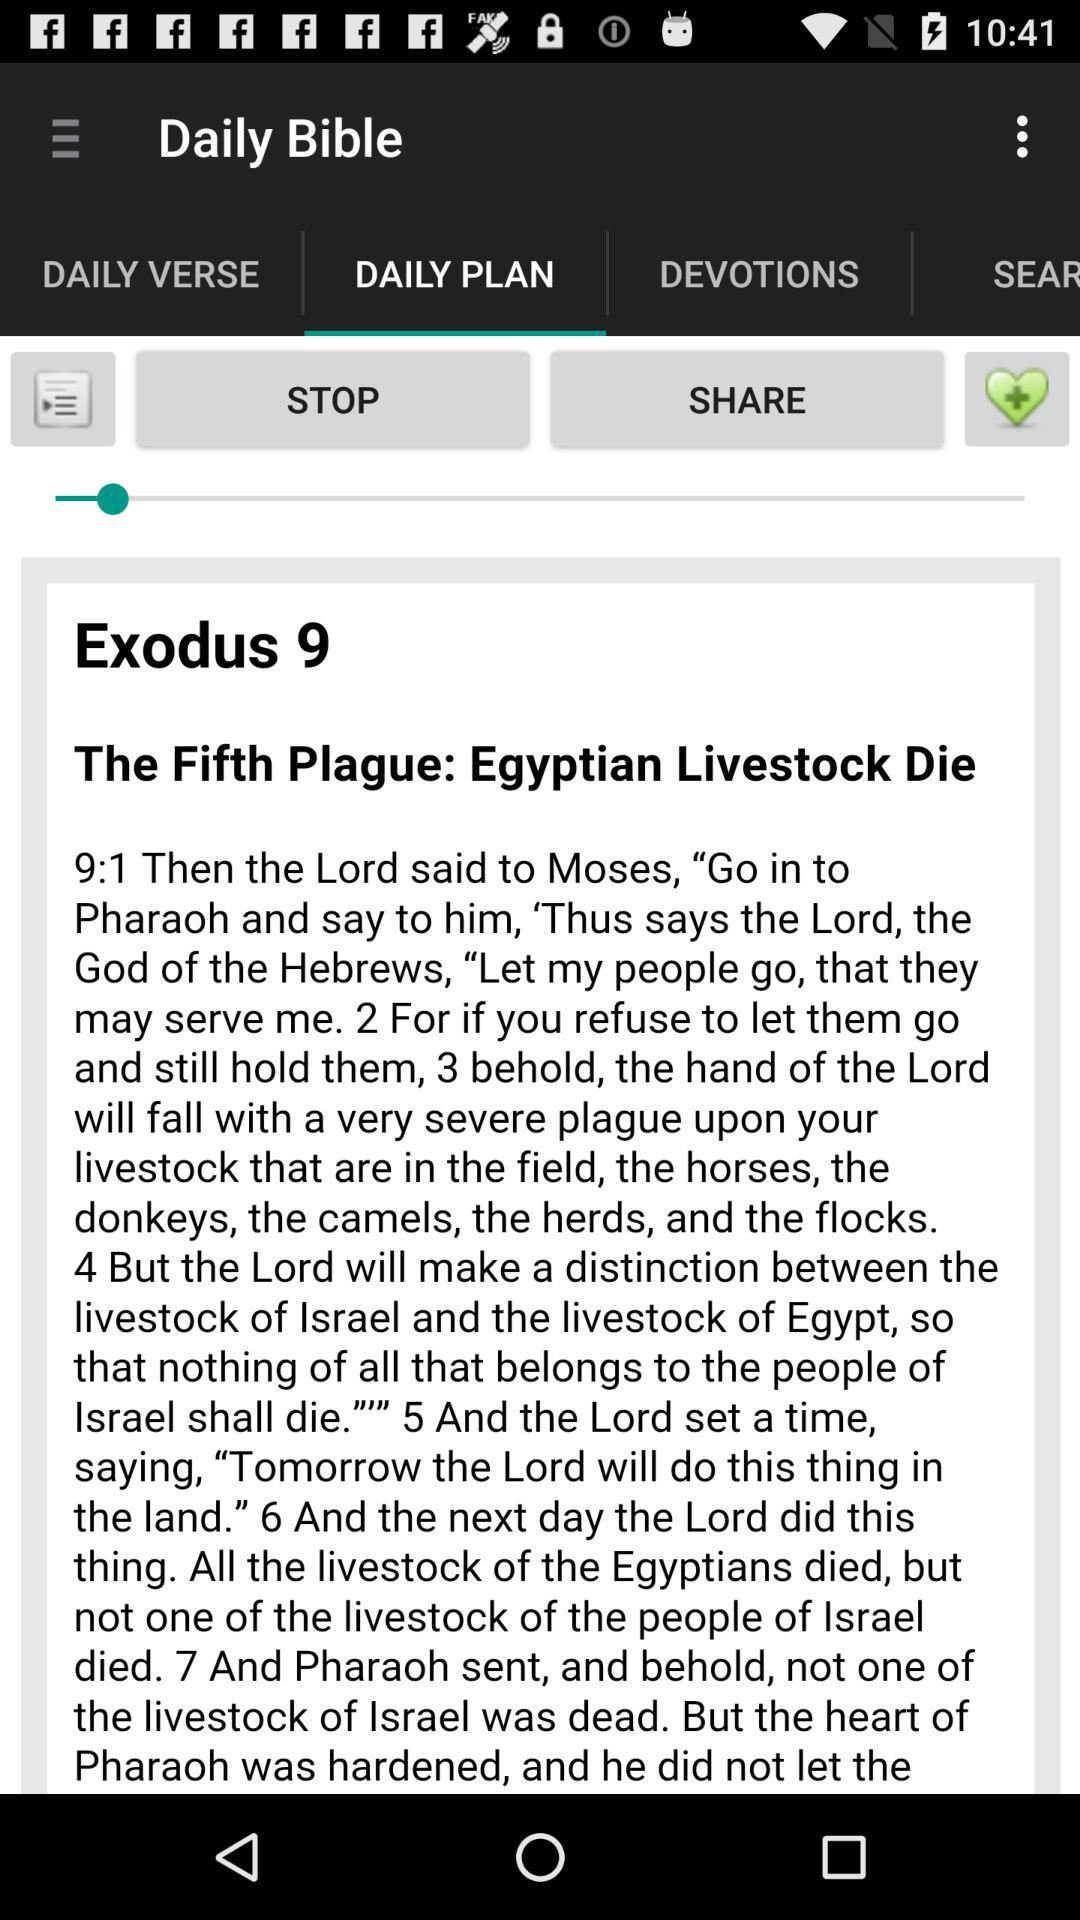Which tab is selected? The selected tab is "DAILY PLAN". 